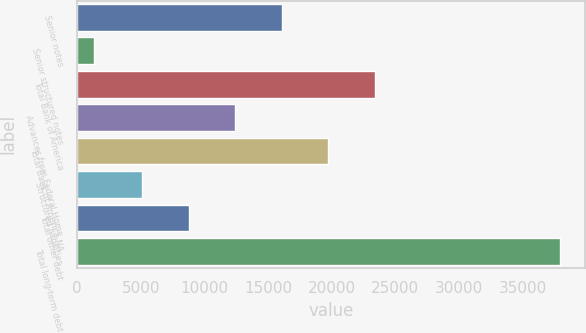Convert chart to OTSL. <chart><loc_0><loc_0><loc_500><loc_500><bar_chart><fcel>Senior notes<fcel>Senior structured notes<fcel>Total Bank of America<fcel>Advances from Federal Home<fcel>Total Bank of America NA<fcel>Structured liabilities<fcel>Total other debt<fcel>Total long-term debt<nl><fcel>16076.4<fcel>1337<fcel>23404<fcel>12412.6<fcel>19740.2<fcel>5085<fcel>8748.8<fcel>37975<nl></chart> 